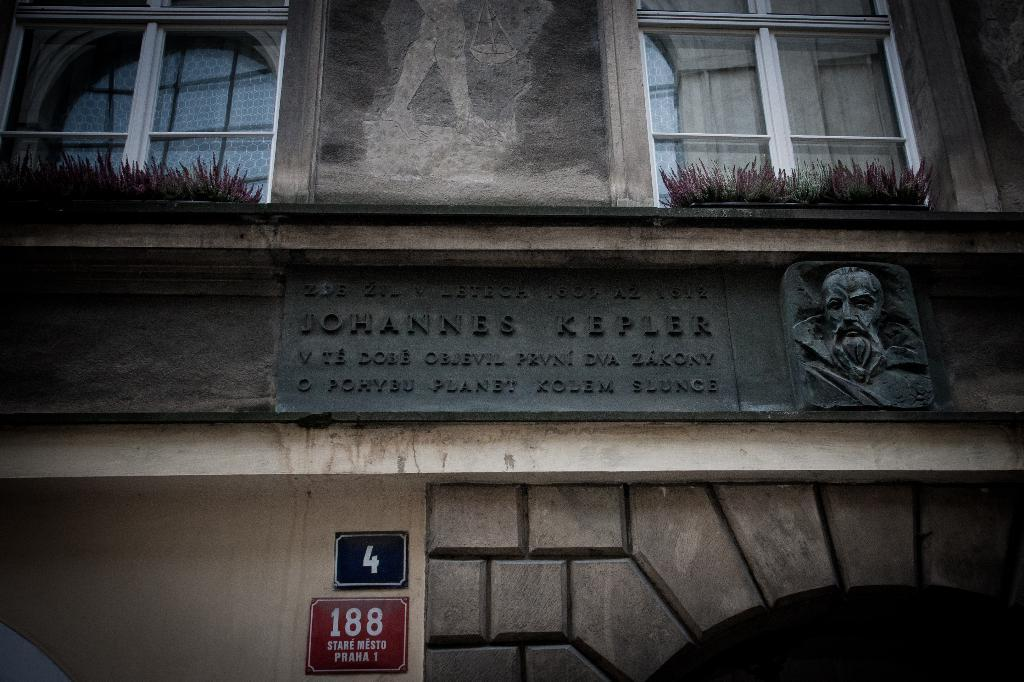What type of structure is visible in the image? There is a building in the image. What feature can be observed on the building? The building has glass windows. Is there any artwork or design on the building? Yes, there is a face of a man on the wall in the image. What else can be seen in the image related to vehicles? There are number plate boards in the image. What color is the tongue of the man depicted on the wall in the image? There is no tongue visible in the image, as the face of the man on the wall does not have a mouth or any facial features that would include a tongue. 